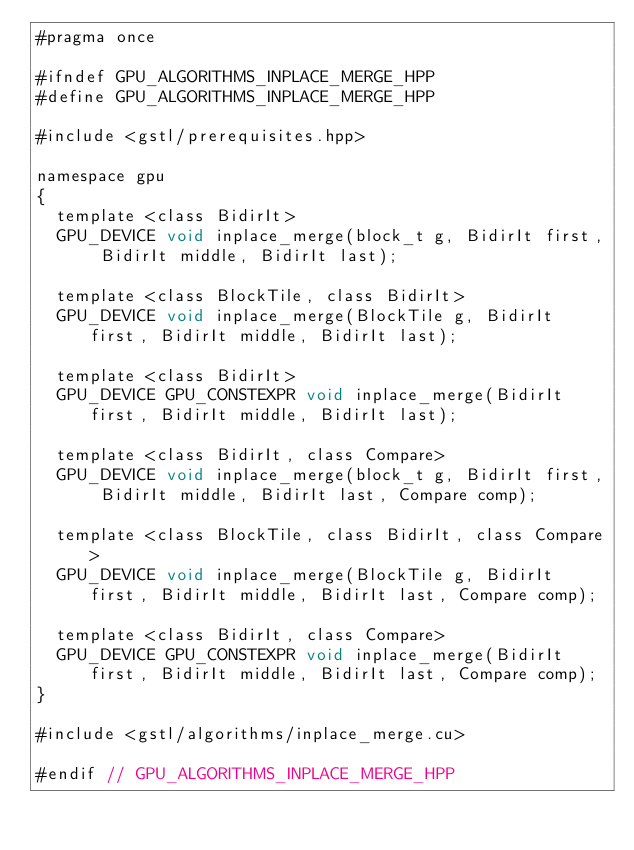Convert code to text. <code><loc_0><loc_0><loc_500><loc_500><_Cuda_>#pragma once

#ifndef GPU_ALGORITHMS_INPLACE_MERGE_HPP
#define GPU_ALGORITHMS_INPLACE_MERGE_HPP

#include <gstl/prerequisites.hpp>

namespace gpu
{
	template <class BidirIt>
	GPU_DEVICE void inplace_merge(block_t g, BidirIt first, BidirIt middle, BidirIt last);

	template <class BlockTile, class BidirIt>
	GPU_DEVICE void inplace_merge(BlockTile g, BidirIt first, BidirIt middle, BidirIt last);

	template <class BidirIt>
	GPU_DEVICE GPU_CONSTEXPR void inplace_merge(BidirIt first, BidirIt middle, BidirIt last);

	template <class BidirIt, class Compare>
	GPU_DEVICE void inplace_merge(block_t g, BidirIt first, BidirIt middle, BidirIt last, Compare comp);

	template <class BlockTile, class BidirIt, class Compare>
	GPU_DEVICE void inplace_merge(BlockTile g, BidirIt first, BidirIt middle, BidirIt last, Compare comp);

	template <class BidirIt, class Compare>
	GPU_DEVICE GPU_CONSTEXPR void inplace_merge(BidirIt first, BidirIt middle, BidirIt last, Compare comp);
}

#include <gstl/algorithms/inplace_merge.cu>

#endif // GPU_ALGORITHMS_INPLACE_MERGE_HPP
</code> 